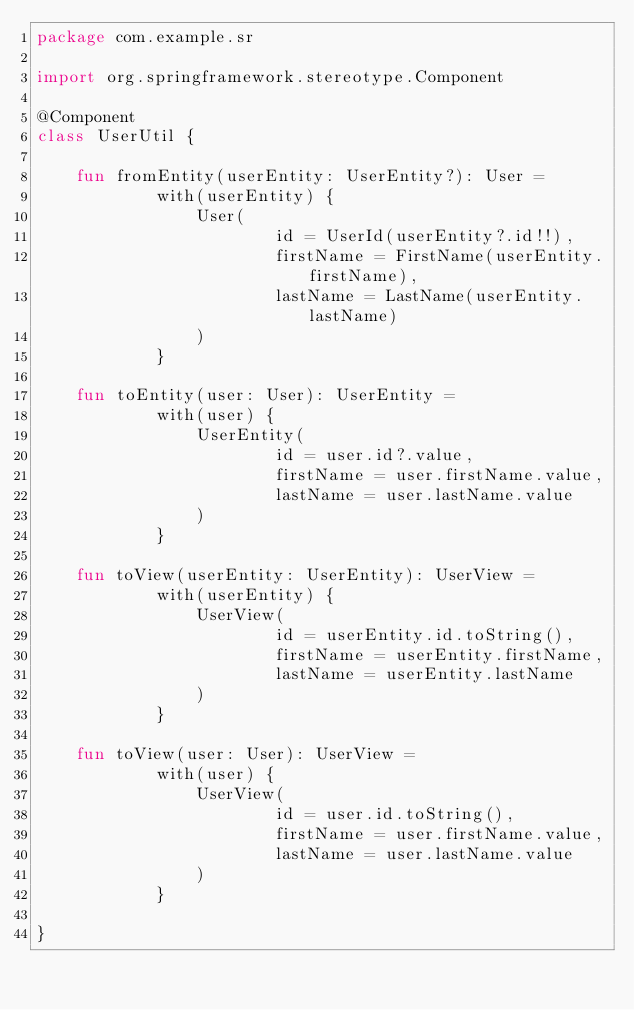Convert code to text. <code><loc_0><loc_0><loc_500><loc_500><_Kotlin_>package com.example.sr

import org.springframework.stereotype.Component

@Component
class UserUtil {

    fun fromEntity(userEntity: UserEntity?): User =
            with(userEntity) {
                User(
                        id = UserId(userEntity?.id!!),
                        firstName = FirstName(userEntity.firstName),
                        lastName = LastName(userEntity.lastName)
                )
            }

    fun toEntity(user: User): UserEntity =
            with(user) {
                UserEntity(
                        id = user.id?.value,
                        firstName = user.firstName.value,
                        lastName = user.lastName.value
                )
            }

    fun toView(userEntity: UserEntity): UserView =
            with(userEntity) {
                UserView(
                        id = userEntity.id.toString(),
                        firstName = userEntity.firstName,
                        lastName = userEntity.lastName
                )
            }

    fun toView(user: User): UserView =
            with(user) {
                UserView(
                        id = user.id.toString(),
                        firstName = user.firstName.value,
                        lastName = user.lastName.value
                )
            }

}</code> 